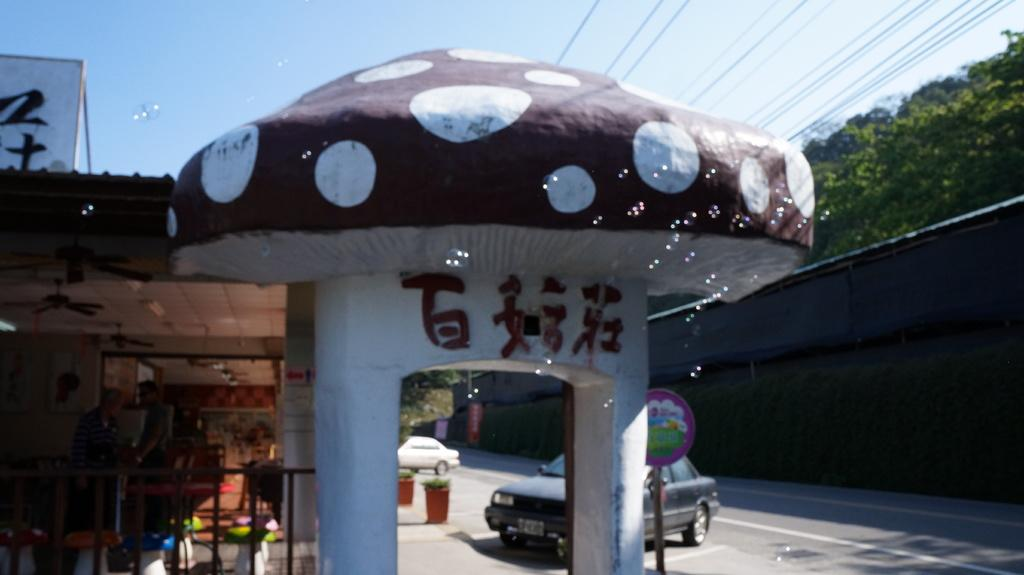What type of structures can be seen in the image? There are houses in the image. What mode of transportation is present on the road in the image? There are cars on the road in the image. What is the purpose of the sign board in the image? The purpose of the sign board in the image is to provide information or directions. What type of vegetation is present in the image? There are plants in the image. What type of infrastructure is visible in the image? Cables are visible in the image. Can you tell me how many cats are sitting on the roof of the houses in the image? There are no cats present in the image; it only features houses, cars, a sign board, plants, and cables. What type of music is being played by the band in the image? There is no band present in the image; it only features houses, cars, a sign board, plants, and cables. 